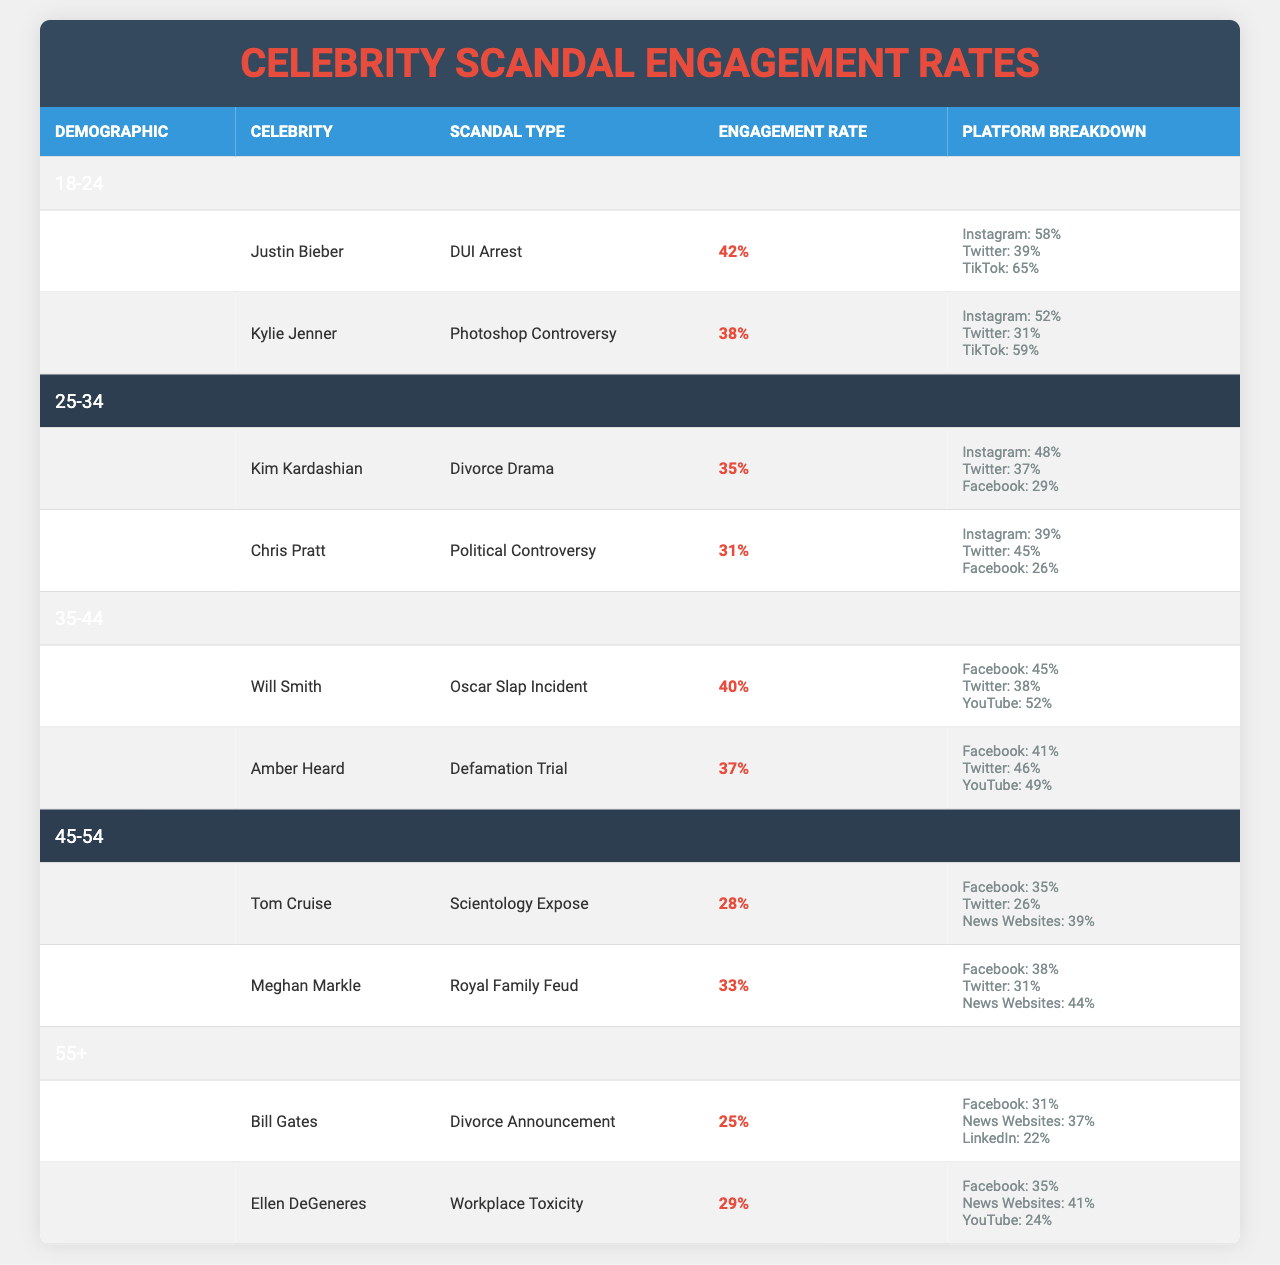What is the highest engagement rate in the 18-24 demographic? Among the scandals listed for the 18-24 demographic, Justin Bieber's DUI Arrest has the highest engagement rate of 42%.
Answer: 42% Which celebrity scandal had the lowest engagement rate in the 45-54 demographic? Tom Cruise's Scientology Expose had the lowest engagement rate at 28% among the scandals in the 45-54 demographic.
Answer: 28% What is the average engagement rate for Kim Kardashian and Chris Pratt? To find the average, we add Kim Kardashian's engagement rate (35%) and Chris Pratt's (31%), which equals 66%. Dividing by 2 gives an average engagement rate of 33%.
Answer: 33% Is the engagement rate for the Oscars Slap Incident higher than that of the Divorce Drama? Will Smith's Oscar Slap Incident engagement rate is 40%, which is higher than Kim Kardashian's Divorce Drama at 35%, making the statement true.
Answer: Yes Who had a higher engagement rate: Justin Bieber or Kylie Jenner? Justin Bieber's engagement rate for his scandal is 42%, while Kylie Jenner's is 38%. Since 42% is greater than 38%, Bieber had a higher engagement rate.
Answer: Justin Bieber What platforms generate the most engagement for Kylie Jenner's scandal? The platform breakdown shows that Instagram leads with 52%, followed by TikTok at 59%, and Twitter at 31%.
Answer: Instagram and TikTok In the 35-44 age group, which scandal's engagement rate is closest to the average engagement rate of all the scandals? Will Smith's Oscar Slap Incident (40%) and Amber Heard's Defamation Trial (37%) can be averaged to 38.5%. Since both are close to this average, they should be checked against the average of other categories for precision; hence, the engagement closest is Amber Heard at 37%.
Answer: 37% What is the combined engagement rate for the scandals in the 55+ demographic? The engagement rates for Bill Gates (25%) and Ellen DeGeneres (29%) sum up to 54%. Hence, the combined engagement rate is 54%.
Answer: 54% Did any scandal in the 25-34 demographic have above 30% engagement on Twitter? Chris Pratt's political controversy has an engagement rate of 45% on Twitter, exceeding 30%, confirming the statement is true.
Answer: Yes How does the engagement rate for Meghan Markle's Royal Family Feud compare to Tom Cruise's Scientology Expose? Meghan Markle's engagement rate (33%) is higher than Tom Cruise's (28%). Therefore, Markle's rate is greater.
Answer: Higher 